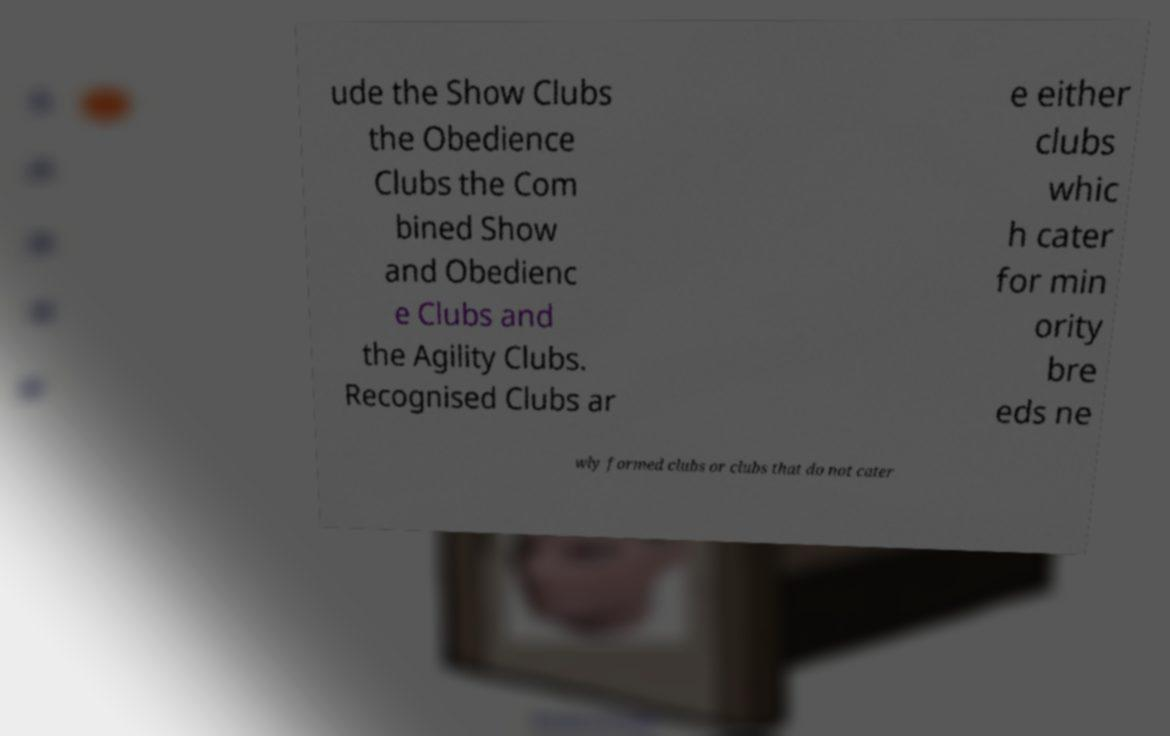Can you accurately transcribe the text from the provided image for me? ude the Show Clubs the Obedience Clubs the Com bined Show and Obedienc e Clubs and the Agility Clubs. Recognised Clubs ar e either clubs whic h cater for min ority bre eds ne wly formed clubs or clubs that do not cater 